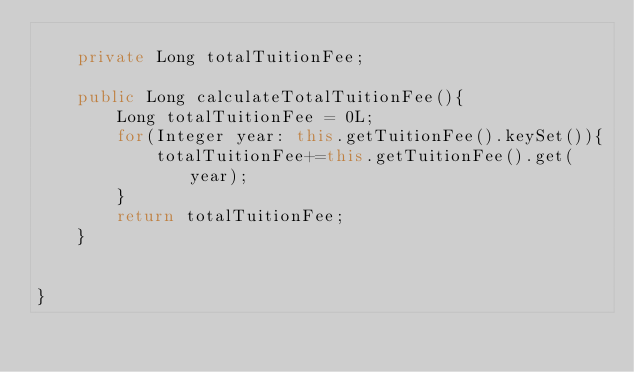Convert code to text. <code><loc_0><loc_0><loc_500><loc_500><_Java_>
    private Long totalTuitionFee;

    public Long calculateTotalTuitionFee(){
        Long totalTuitionFee = 0L;
        for(Integer year: this.getTuitionFee().keySet()){
            totalTuitionFee+=this.getTuitionFee().get(year);
        }
        return totalTuitionFee;
    }


}
</code> 